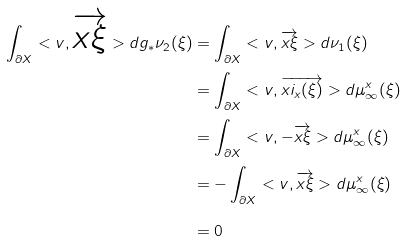Convert formula to latex. <formula><loc_0><loc_0><loc_500><loc_500>\int _ { \partial X } < v , \overrightarrow { x \xi } > d g _ { * } \nu _ { 2 } ( \xi ) & = \int _ { \partial X } < v , \overrightarrow { x \xi } > d \nu _ { 1 } ( \xi ) \\ & = \int _ { \partial X } < v , \overrightarrow { x i _ { x } ( \xi ) } > d \mu ^ { x } _ { \infty } ( \xi ) \\ & = \int _ { \partial X } < v , - \overrightarrow { x \xi } > d \mu ^ { x } _ { \infty } ( \xi ) \\ & = - \int _ { \partial X } < v , \overrightarrow { x \xi } > d \mu ^ { x } _ { \infty } ( \xi ) \\ & = 0 \\</formula> 